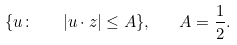Convert formula to latex. <formula><loc_0><loc_0><loc_500><loc_500>\{ u \colon \quad | u \cdot z | \leq A \} , \quad A = \frac { 1 } { 2 } .</formula> 